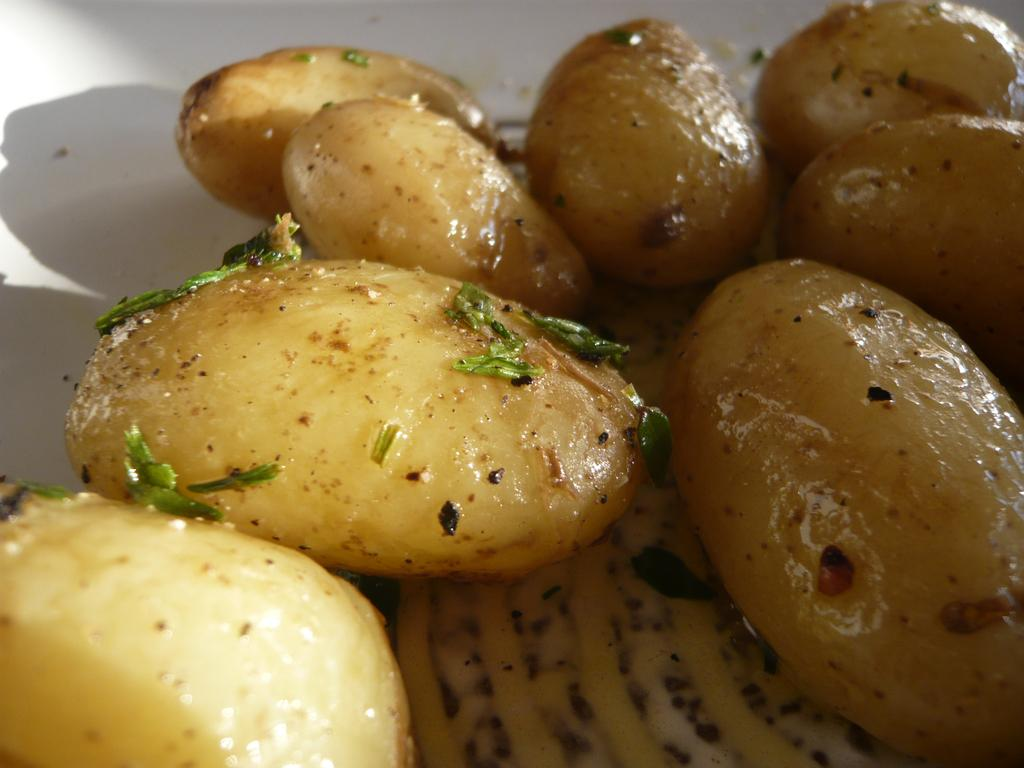What is on the plate that is visible in the image? There is food on a white plate in the image. What type of boat is visible in the image? There is no boat present in the image; it only features food on a white plate. How many quivers can be seen in the image? There are no quivers present in the image. 